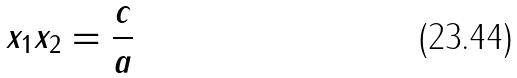<formula> <loc_0><loc_0><loc_500><loc_500>x _ { 1 } x _ { 2 } = \frac { c } { a }</formula> 